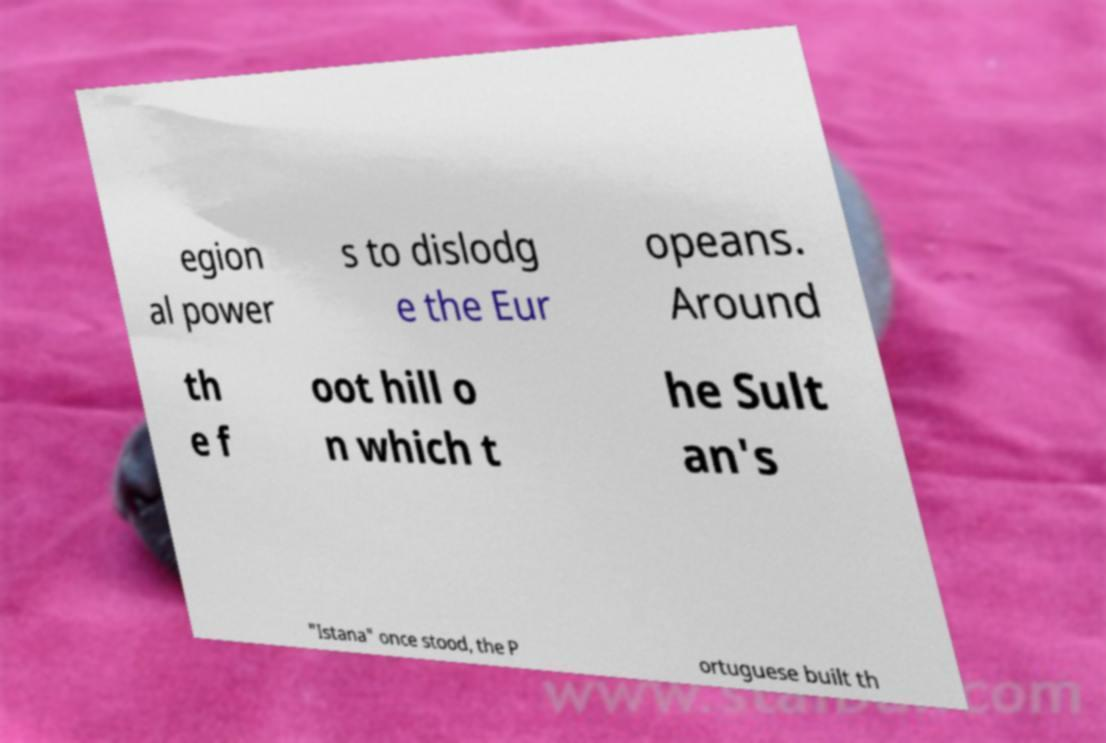Can you read and provide the text displayed in the image?This photo seems to have some interesting text. Can you extract and type it out for me? egion al power s to dislodg e the Eur opeans. Around th e f oot hill o n which t he Sult an's "Istana" once stood, the P ortuguese built th 